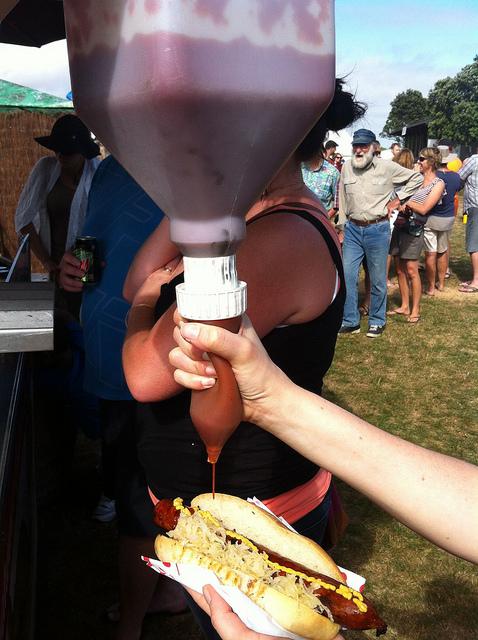What is the person squeezing?
Be succinct. Ketchup. Do any men have facial hair?
Quick response, please. Yes. What are they squeezing?
Answer briefly. Ketchup. 